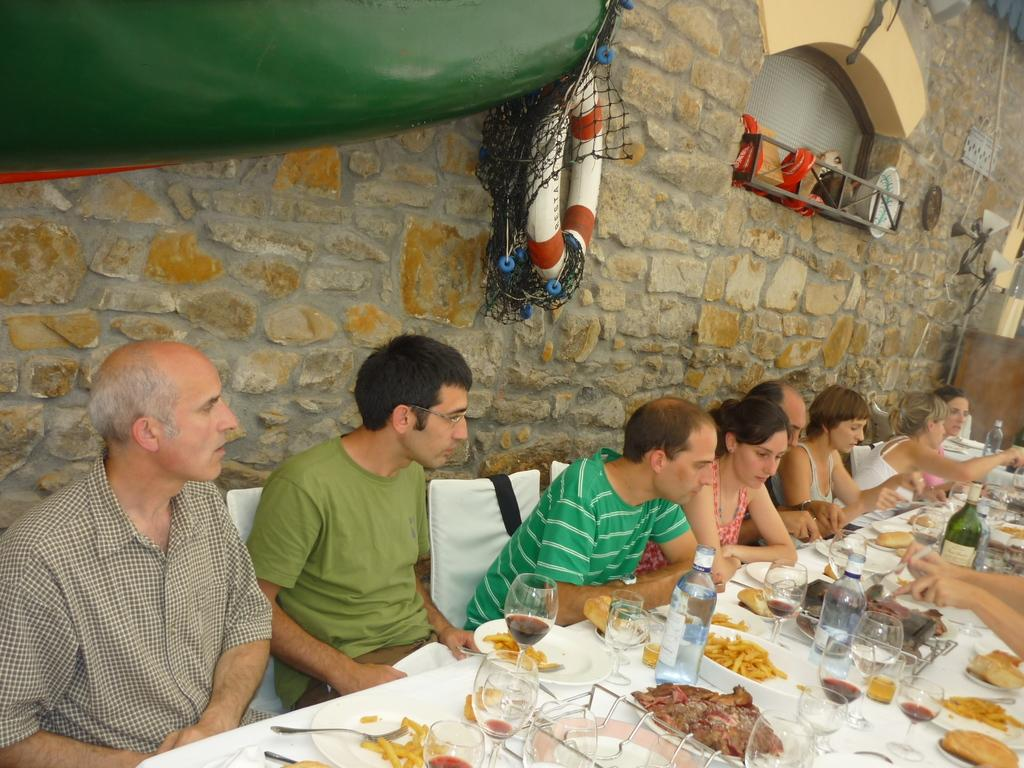How many people are in the image? There is a group of people in the image. What are the people doing in the image? The people are seated on chairs. What can be seen on the table in the image? There are bottles, food, wine glasses, and wine bottles on the table. Which direction is the receipt pointing in the image? There is no receipt present in the image. How many ducks are visible in the image? There are no ducks present in the image. 